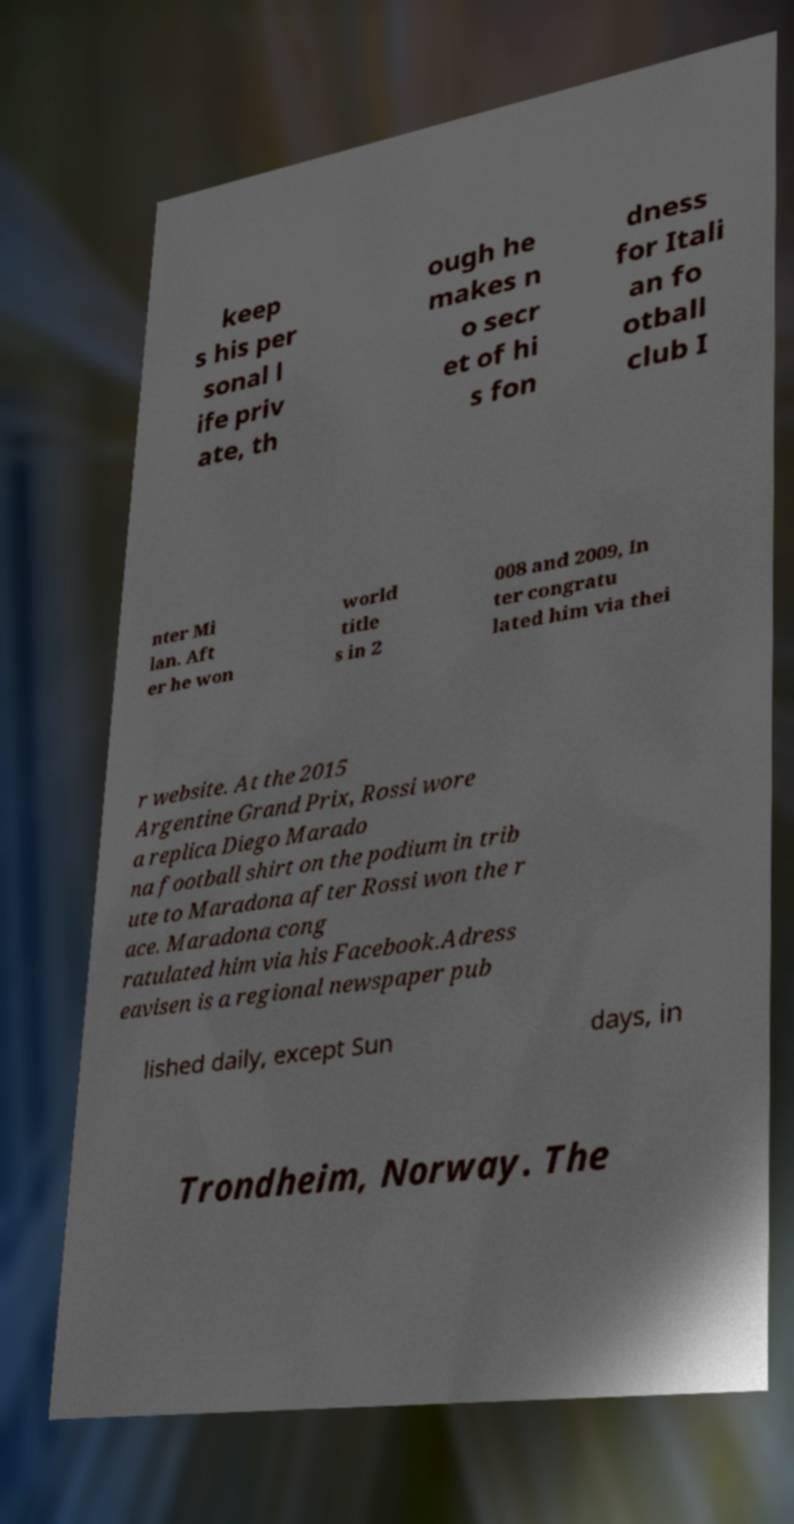Please read and relay the text visible in this image. What does it say? keep s his per sonal l ife priv ate, th ough he makes n o secr et of hi s fon dness for Itali an fo otball club I nter Mi lan. Aft er he won world title s in 2 008 and 2009, In ter congratu lated him via thei r website. At the 2015 Argentine Grand Prix, Rossi wore a replica Diego Marado na football shirt on the podium in trib ute to Maradona after Rossi won the r ace. Maradona cong ratulated him via his Facebook.Adress eavisen is a regional newspaper pub lished daily, except Sun days, in Trondheim, Norway. The 